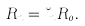<formula> <loc_0><loc_0><loc_500><loc_500>R _ { n } = \lambda _ { n } R _ { 0 } .</formula> 